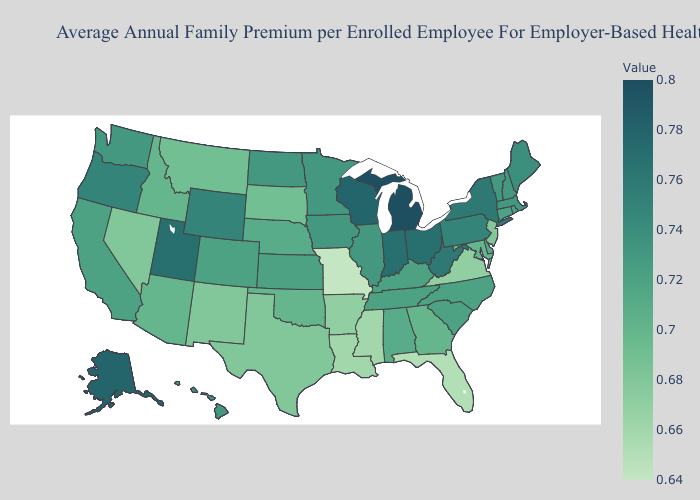Which states have the lowest value in the South?
Quick response, please. Florida. Does New Hampshire have a higher value than Utah?
Quick response, please. No. Which states hav the highest value in the South?
Answer briefly. West Virginia. Among the states that border Virginia , does West Virginia have the highest value?
Give a very brief answer. Yes. Among the states that border Nebraska , which have the highest value?
Be succinct. Wyoming. 